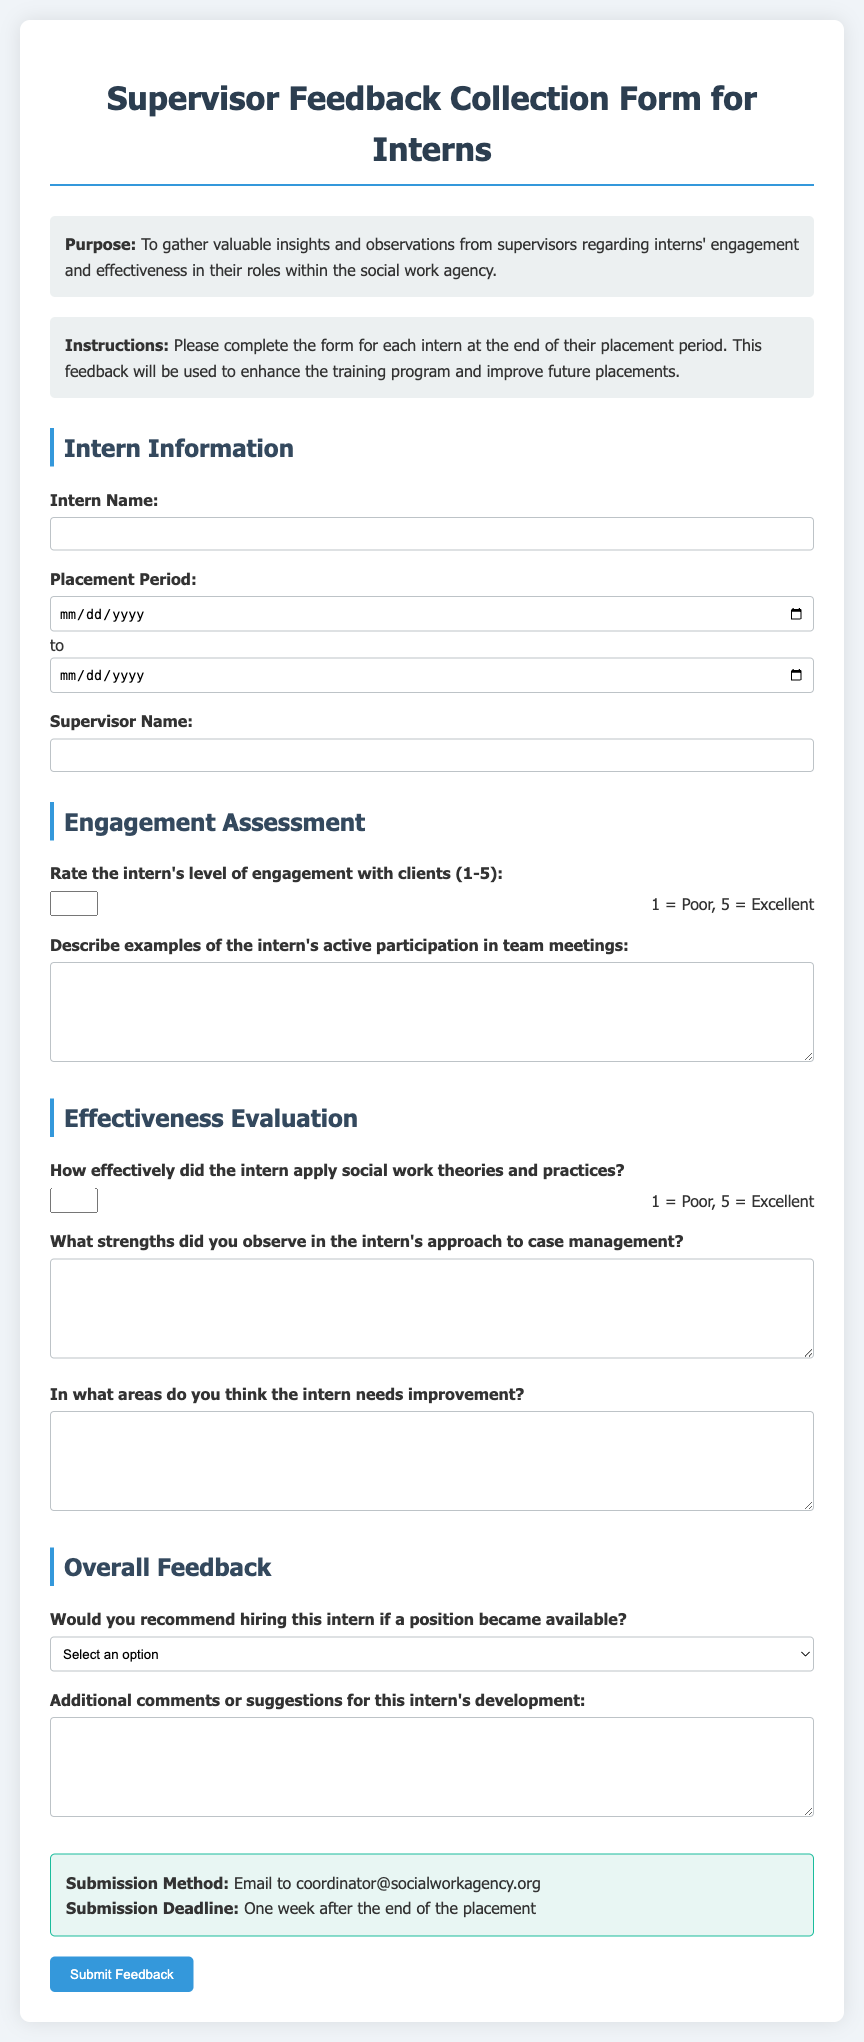What is the purpose of this form? The purpose of the form is outlined in the "Purpose" section at the top, which states it is to gather insights and observations from supervisors about interns' engagement and effectiveness.
Answer: To gather valuable insights and observations from supervisors regarding interns' engagement and effectiveness in their roles within the social work agency What is the submission deadline for the feedback? The deadline is specified in the "Submission Details" section, indicating when feedback should be submitted after the placement ends.
Answer: One week after the end of the placement Who should the feedback be submitted to? The submission method section mentions where to send the completed feedback form.
Answer: coordinator@socialworkagency.org What scale is used to rate the intern's level of engagement? The scale is mentioned in the engagement assessment section, describing the range used for scoring the intern's engagement.
Answer: 1-5 What information is required about the intern? The form provides a section where specific details about the intern need to be entered, indicating essential data to collect.
Answer: Intern Name, Placement Period, Supervisor Name What type of comment is requested for the intern's participation in team meetings? The form specifically asks for a description of examples regarding the intern's participation, indicating a qualitative assessment.
Answer: Describe examples of the intern's active participation in team meetings How are the effectiveness and application of social work theories rated? The rating for the effectiveness of applying theories is found in the effectiveness evaluation section, detailing how supervisors express this judgment.
Answer: 1-5 What is the first field to fill out in the intern information section? The order of fields in the intern information section indicates which piece of data to enter first.
Answer: Intern Name 